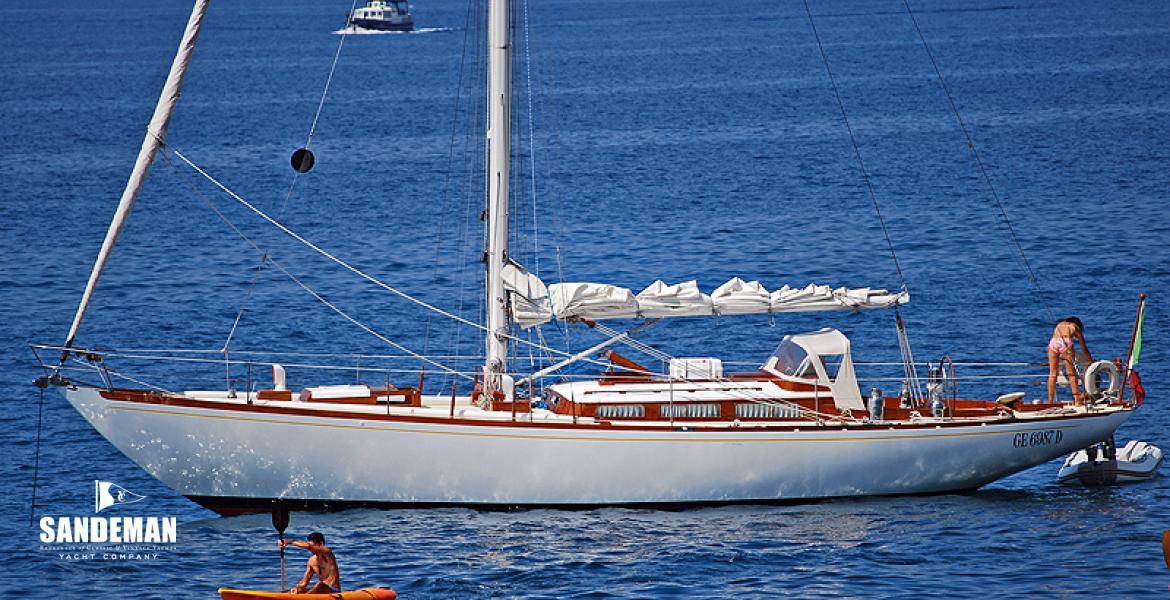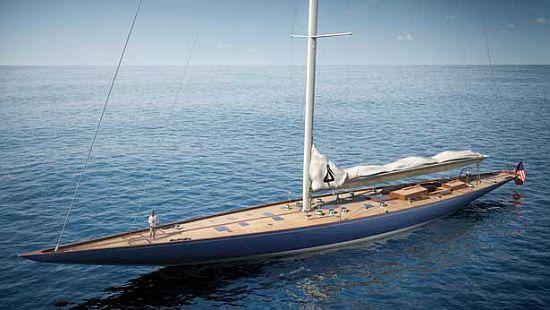The first image is the image on the left, the second image is the image on the right. Examine the images to the left and right. Is the description "One boat contains multiple people and creates white spray as it moves through water with unfurled sails, while the other boat is still and has furled sails." accurate? Answer yes or no. No. The first image is the image on the left, the second image is the image on the right. Considering the images on both sides, is "The left and right image contains the same number of sailboats with one with no sails out." valid? Answer yes or no. No. 